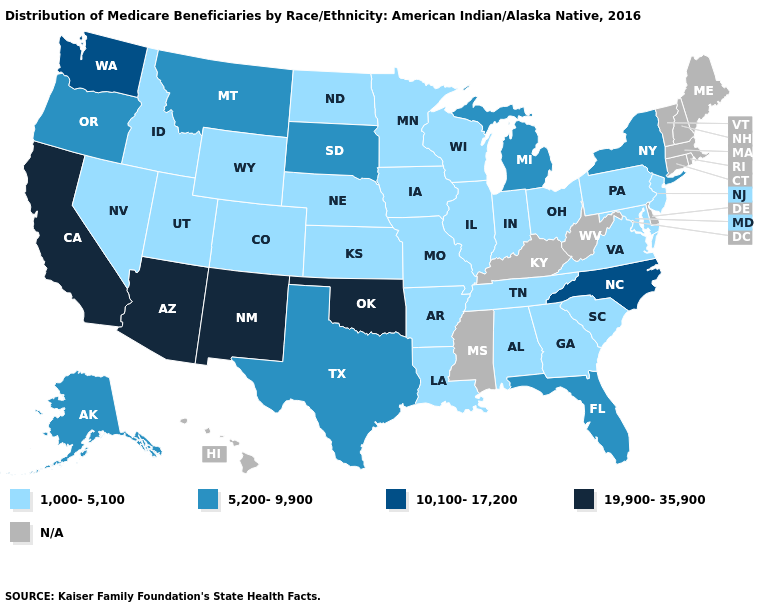Name the states that have a value in the range 19,900-35,900?
Concise answer only. Arizona, California, New Mexico, Oklahoma. Which states have the lowest value in the USA?
Concise answer only. Alabama, Arkansas, Colorado, Georgia, Idaho, Illinois, Indiana, Iowa, Kansas, Louisiana, Maryland, Minnesota, Missouri, Nebraska, Nevada, New Jersey, North Dakota, Ohio, Pennsylvania, South Carolina, Tennessee, Utah, Virginia, Wisconsin, Wyoming. Which states have the lowest value in the USA?
Short answer required. Alabama, Arkansas, Colorado, Georgia, Idaho, Illinois, Indiana, Iowa, Kansas, Louisiana, Maryland, Minnesota, Missouri, Nebraska, Nevada, New Jersey, North Dakota, Ohio, Pennsylvania, South Carolina, Tennessee, Utah, Virginia, Wisconsin, Wyoming. What is the highest value in the USA?
Write a very short answer. 19,900-35,900. Which states have the lowest value in the USA?
Give a very brief answer. Alabama, Arkansas, Colorado, Georgia, Idaho, Illinois, Indiana, Iowa, Kansas, Louisiana, Maryland, Minnesota, Missouri, Nebraska, Nevada, New Jersey, North Dakota, Ohio, Pennsylvania, South Carolina, Tennessee, Utah, Virginia, Wisconsin, Wyoming. What is the value of Maryland?
Concise answer only. 1,000-5,100. What is the highest value in states that border Massachusetts?
Give a very brief answer. 5,200-9,900. What is the value of Kansas?
Quick response, please. 1,000-5,100. Name the states that have a value in the range 10,100-17,200?
Keep it brief. North Carolina, Washington. Does the map have missing data?
Quick response, please. Yes. Does the first symbol in the legend represent the smallest category?
Answer briefly. Yes. What is the value of Delaware?
Give a very brief answer. N/A. Does Montana have the lowest value in the USA?
Keep it brief. No. What is the value of Delaware?
Write a very short answer. N/A. 